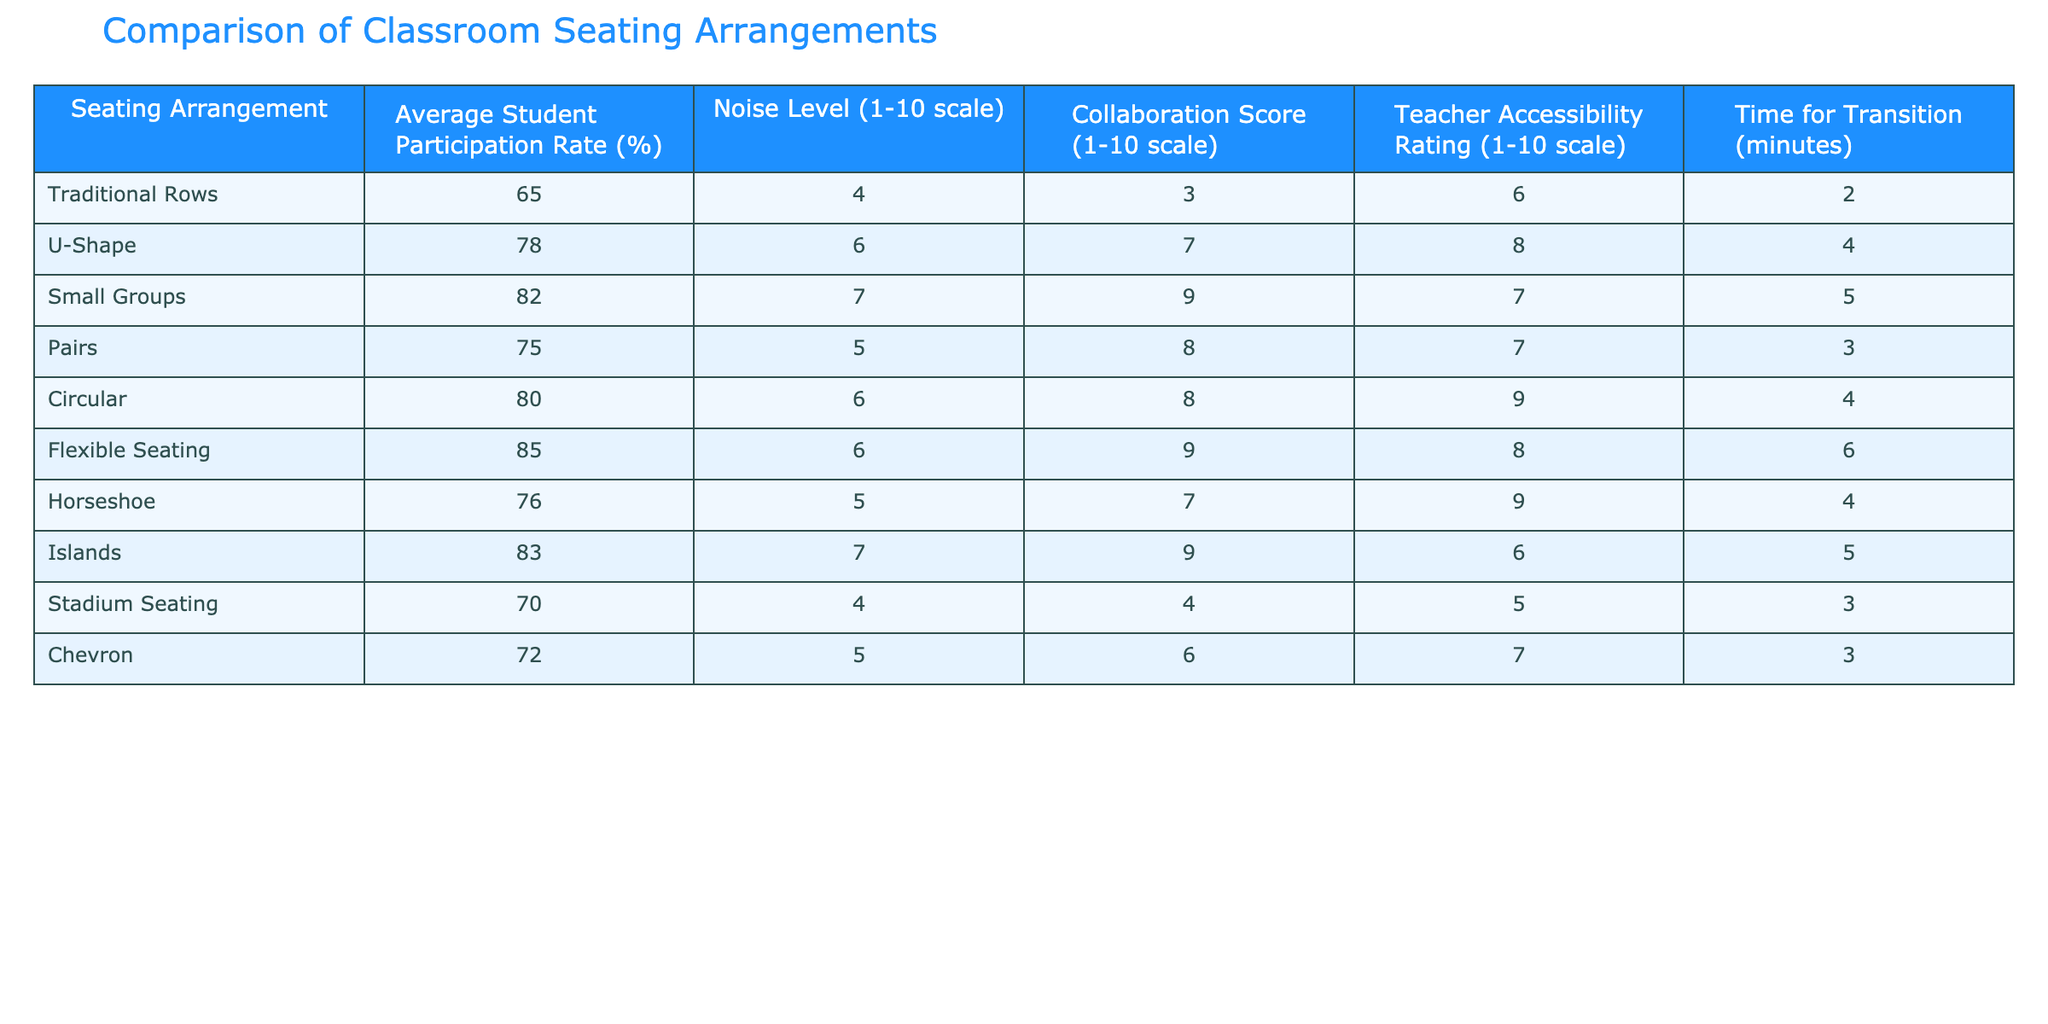What is the average student participation rate for Flexible Seating? The table indicates that the Average Student Participation Rate for Flexible Seating is 85%. This value is directly found in the relevant column of the table corresponding to the Flexible Seating row.
Answer: 85% Which seating arrangement has the highest collaboration score? Flexible Seating has the highest Collaboration Score of 9, as observed by comparing the scores in the Collaboration Score column across all seating arrangements in the table.
Answer: Flexible Seating What is the noise level for Small Groups? The Noise Level for Small Groups is 7, as indicated in the Noise Level column corresponding to the Small Groups row in the table.
Answer: 7 Is the average student participation rate for U-Shape greater than that of Traditional Rows? Yes, the Average Student Participation Rate for the U-Shape arrangement is 78%, which is indeed greater than the 65% for Traditional Rows. This comparison is made by looking at the respective values in their rows.
Answer: Yes What is the difference in average student participation between Circular and Pairs seating arrangements? The average student participation rate for Circular seating is 80%, and for Pairs it is 75%. The difference can be calculated as 80 - 75 = 5. Thus, the insights indicate Circular yields a higher participation rate by 5 percentage points compared to Pairs.
Answer: 5 Which seating arrangement provides the best teacher accessibility rating? The Horseshoe seating arrangement has the best Teacher Accessibility Rating of 9. This is determined by examining all the Teacher Accessibility Ratings from the table and identifying the highest value, which corresponds to Horseshoe.
Answer: Horseshoe If we were to average the noise levels of Traditional Rows and Stadium Seating, what would that value be? The Noise Level for Traditional Rows is 4 and for Stadium Seating is also 4. The average is calculated as (4 + 4) / 2 = 4. Both rows reveal the same noise level, leading to a straightforward average calculation.
Answer: 4 How many seating arrangements have an average participation rate above 75%? There are five seating arrangements with average participation rates above 75%: Small Groups (82%), Flexible Seating (85%), Circular (80%), Islands (83%), and U-Shape (78%). This count is determined by listing the arrangements that meet the criterion and tallying them up.
Answer: 5 What is the time for transition for the Flexible Seating arrangement? The time for transition for Flexible Seating is 6 minutes. This value can be found directly in the Time for Transition column corresponding to Flexible Seating in the table.
Answer: 6 